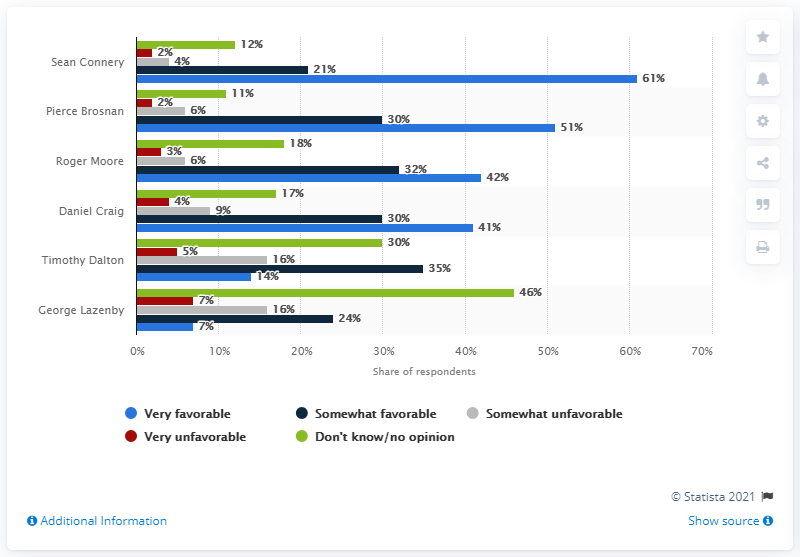What percentage of respondents have no opinion about Timothy Dalton? Approximately 35% of respondents don't have an opinion on Timothy Dalton's portrayal of James Bond, which indicates a less memorable or impactful depiction in the eyes of many viewers. 